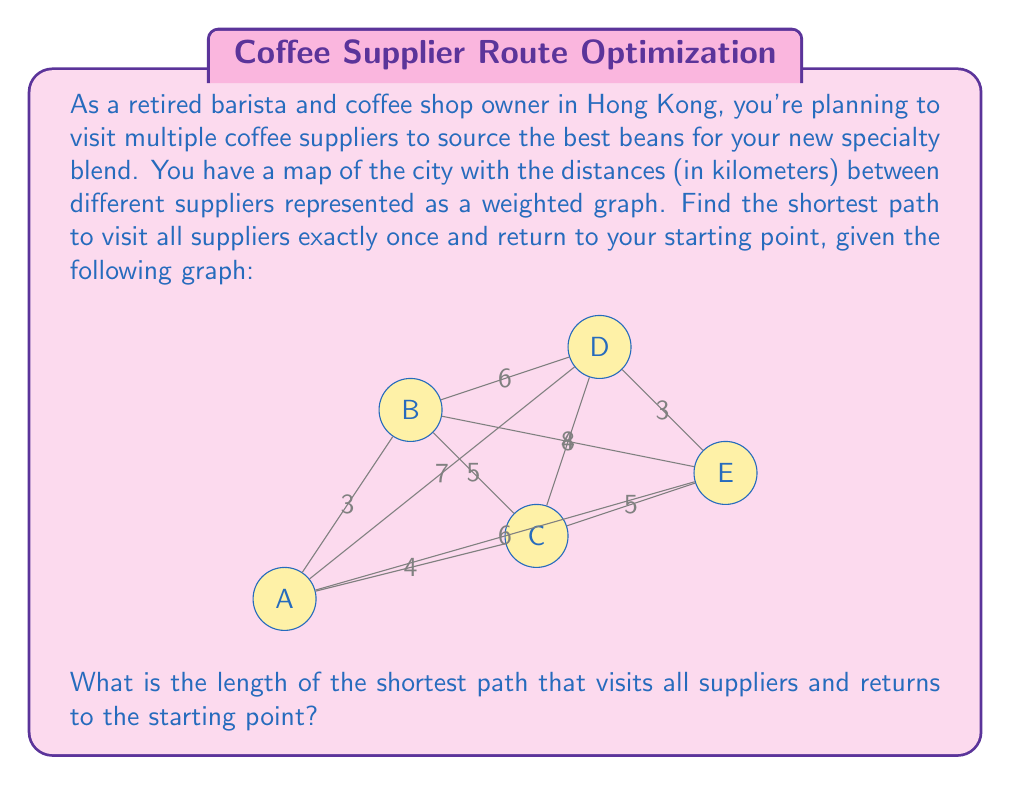Could you help me with this problem? To solve this problem, we need to find the Hamiltonian cycle with the minimum total weight in the given graph. This is known as the Traveling Salesman Problem (TSP).

For a small graph like this, we can use a brute-force approach to find the optimal solution:

1. List all possible Hamiltonian cycles:
   ABCDEA, ABCEDA, ABDCEA, ABDECA, ABEDCA, ABECDA
   ACBDEA, ACBEDA, ACDEBA, ACDEBA, ACEDBA, ACEBDA
   ADCBEA, ADCEBA, ADBCEA, ADBECA, ADEBCA, ADECBA
   AEDCBA, AEDCBA, AEBCDA, AEBDCA, AECBDA, AECDBA

2. Calculate the total distance for each cycle:
   ABCDEA: 3 + 5 + 4 + 3 + 6 = 21
   ABCEDA: 3 + 5 + 5 + 3 + 6 = 22
   ABDCEA: 3 + 6 + 4 + 5 + 6 = 24
   ABDECA: 3 + 6 + 3 + 5 + 6 = 23
   ABEDCA: 3 + 8 + 3 + 4 + 6 = 24
   ABECDA: 3 + 8 + 5 + 4 + 6 = 26
   ACBDEA: 4 + 5 + 6 + 3 + 6 = 24
   ACBEDA: 4 + 5 + 8 + 3 + 6 = 26
   ACDEBA: 4 + 4 + 3 + 8 + 6 = 25
   ACEDBA: 4 + 5 + 3 + 6 + 6 = 24
   ACEBDA: 4 + 5 + 8 + 6 + 6 = 29
   ADCBEA: 7 + 4 + 5 + 8 + 6 = 30
   ADCEBA: 7 + 4 + 5 + 3 + 6 = 25
   ADBCEA: 7 + 6 + 5 + 5 + 6 = 29
   ADBECA: 7 + 6 + 8 + 5 + 6 = 32
   ADEBCA: 7 + 3 + 8 + 5 + 6 = 29
   ADECBA: 7 + 3 + 5 + 5 + 6 = 26
   AEDCBA: 6 + 3 + 4 + 5 + 4 = 22
   AEBCDA: 6 + 8 + 5 + 4 + 7 = 30
   AEBDCA: 6 + 8 + 6 + 4 + 7 = 31
   AECBDA: 6 + 5 + 5 + 6 + 7 = 29
   AECDBA: 6 + 5 + 4 + 6 + 7 = 28

3. Identify the cycle with the minimum total distance:
   The shortest path is ABCDEA with a total distance of 21 km.

This solution ensures that all suppliers are visited exactly once and the barista returns to the starting point while minimizing the total distance traveled.
Answer: The length of the shortest path that visits all suppliers and returns to the starting point is 21 km. 